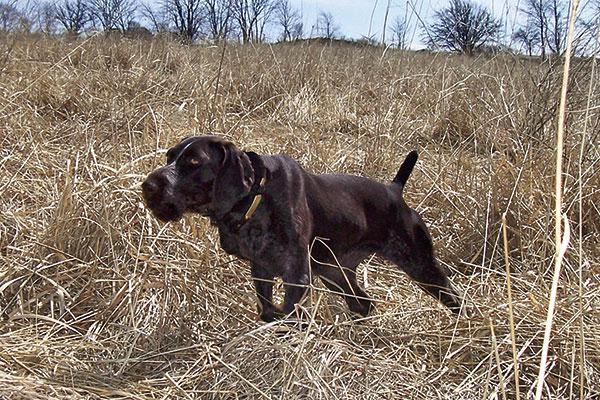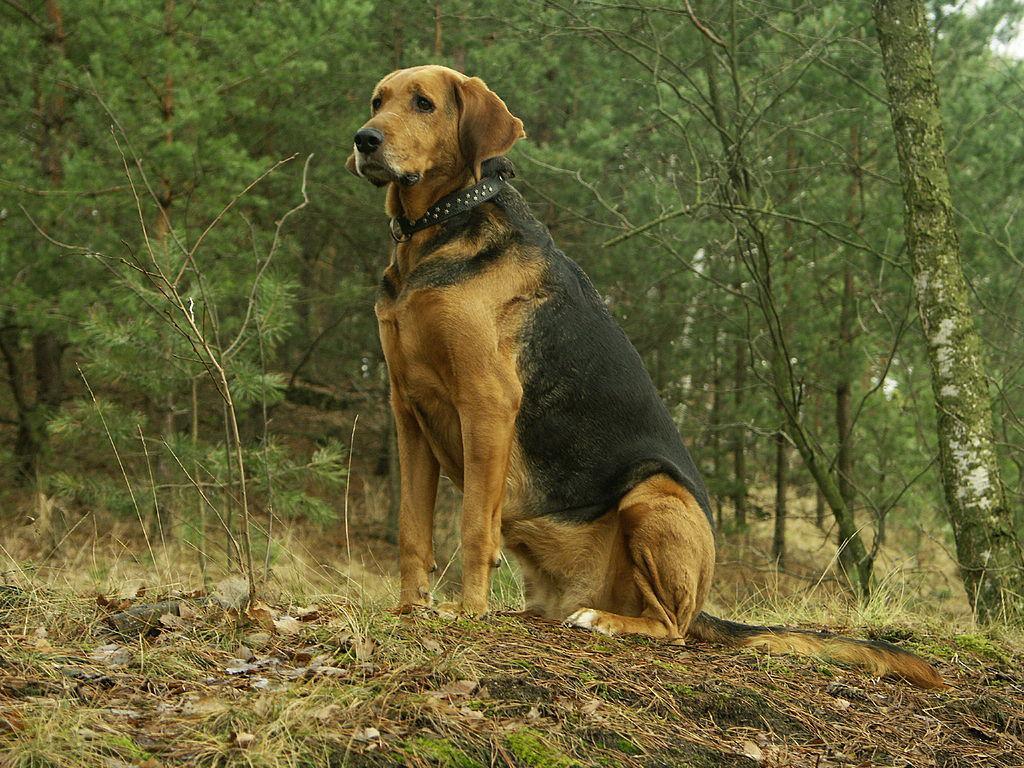The first image is the image on the left, the second image is the image on the right. Analyze the images presented: Is the assertion "The right image features a dog on something elevated, and the left image includes a dog and at least one dead game bird." valid? Answer yes or no. No. The first image is the image on the left, the second image is the image on the right. Considering the images on both sides, is "A dog is sitting in the right image." valid? Answer yes or no. Yes. 